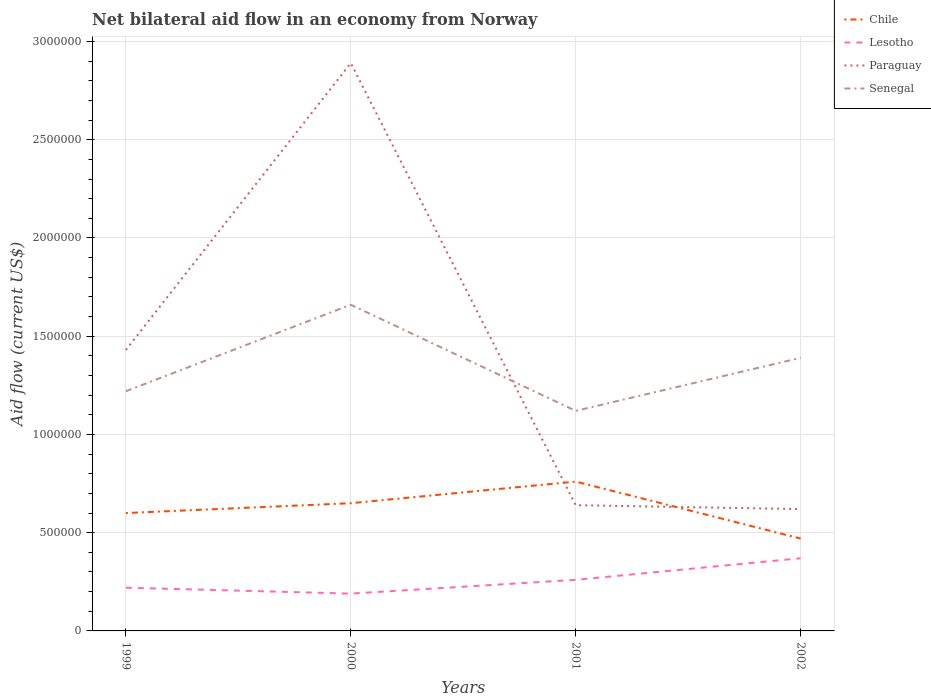Does the line corresponding to Paraguay intersect with the line corresponding to Senegal?
Your response must be concise. Yes. Is the number of lines equal to the number of legend labels?
Offer a very short reply. Yes. What is the difference between the highest and the second highest net bilateral aid flow in Paraguay?
Give a very brief answer. 2.27e+06. What is the difference between the highest and the lowest net bilateral aid flow in Senegal?
Your answer should be very brief. 2. How many lines are there?
Your answer should be compact. 4. How many years are there in the graph?
Your response must be concise. 4. What is the difference between two consecutive major ticks on the Y-axis?
Offer a terse response. 5.00e+05. Does the graph contain any zero values?
Your response must be concise. No. Does the graph contain grids?
Provide a short and direct response. Yes. Where does the legend appear in the graph?
Give a very brief answer. Top right. How are the legend labels stacked?
Offer a terse response. Vertical. What is the title of the graph?
Provide a short and direct response. Net bilateral aid flow in an economy from Norway. Does "Honduras" appear as one of the legend labels in the graph?
Provide a short and direct response. No. What is the label or title of the X-axis?
Ensure brevity in your answer.  Years. What is the Aid flow (current US$) of Paraguay in 1999?
Make the answer very short. 1.43e+06. What is the Aid flow (current US$) of Senegal in 1999?
Offer a terse response. 1.22e+06. What is the Aid flow (current US$) of Chile in 2000?
Make the answer very short. 6.50e+05. What is the Aid flow (current US$) of Paraguay in 2000?
Give a very brief answer. 2.89e+06. What is the Aid flow (current US$) of Senegal in 2000?
Offer a very short reply. 1.66e+06. What is the Aid flow (current US$) of Chile in 2001?
Offer a very short reply. 7.60e+05. What is the Aid flow (current US$) of Lesotho in 2001?
Offer a very short reply. 2.60e+05. What is the Aid flow (current US$) in Paraguay in 2001?
Ensure brevity in your answer.  6.40e+05. What is the Aid flow (current US$) of Senegal in 2001?
Provide a succinct answer. 1.12e+06. What is the Aid flow (current US$) of Chile in 2002?
Provide a succinct answer. 4.70e+05. What is the Aid flow (current US$) of Lesotho in 2002?
Provide a succinct answer. 3.70e+05. What is the Aid flow (current US$) of Paraguay in 2002?
Provide a short and direct response. 6.20e+05. What is the Aid flow (current US$) of Senegal in 2002?
Keep it short and to the point. 1.39e+06. Across all years, what is the maximum Aid flow (current US$) in Chile?
Keep it short and to the point. 7.60e+05. Across all years, what is the maximum Aid flow (current US$) in Lesotho?
Keep it short and to the point. 3.70e+05. Across all years, what is the maximum Aid flow (current US$) in Paraguay?
Offer a terse response. 2.89e+06. Across all years, what is the maximum Aid flow (current US$) in Senegal?
Provide a succinct answer. 1.66e+06. Across all years, what is the minimum Aid flow (current US$) of Paraguay?
Give a very brief answer. 6.20e+05. Across all years, what is the minimum Aid flow (current US$) of Senegal?
Your response must be concise. 1.12e+06. What is the total Aid flow (current US$) of Chile in the graph?
Make the answer very short. 2.48e+06. What is the total Aid flow (current US$) of Lesotho in the graph?
Your answer should be compact. 1.04e+06. What is the total Aid flow (current US$) of Paraguay in the graph?
Provide a succinct answer. 5.58e+06. What is the total Aid flow (current US$) of Senegal in the graph?
Offer a terse response. 5.39e+06. What is the difference between the Aid flow (current US$) of Paraguay in 1999 and that in 2000?
Make the answer very short. -1.46e+06. What is the difference between the Aid flow (current US$) in Senegal in 1999 and that in 2000?
Your answer should be very brief. -4.40e+05. What is the difference between the Aid flow (current US$) of Paraguay in 1999 and that in 2001?
Give a very brief answer. 7.90e+05. What is the difference between the Aid flow (current US$) in Senegal in 1999 and that in 2001?
Provide a short and direct response. 1.00e+05. What is the difference between the Aid flow (current US$) of Chile in 1999 and that in 2002?
Offer a very short reply. 1.30e+05. What is the difference between the Aid flow (current US$) in Paraguay in 1999 and that in 2002?
Your answer should be very brief. 8.10e+05. What is the difference between the Aid flow (current US$) in Paraguay in 2000 and that in 2001?
Offer a very short reply. 2.25e+06. What is the difference between the Aid flow (current US$) in Senegal in 2000 and that in 2001?
Offer a terse response. 5.40e+05. What is the difference between the Aid flow (current US$) in Lesotho in 2000 and that in 2002?
Give a very brief answer. -1.80e+05. What is the difference between the Aid flow (current US$) of Paraguay in 2000 and that in 2002?
Ensure brevity in your answer.  2.27e+06. What is the difference between the Aid flow (current US$) in Lesotho in 2001 and that in 2002?
Ensure brevity in your answer.  -1.10e+05. What is the difference between the Aid flow (current US$) of Senegal in 2001 and that in 2002?
Your response must be concise. -2.70e+05. What is the difference between the Aid flow (current US$) of Chile in 1999 and the Aid flow (current US$) of Lesotho in 2000?
Give a very brief answer. 4.10e+05. What is the difference between the Aid flow (current US$) in Chile in 1999 and the Aid flow (current US$) in Paraguay in 2000?
Your answer should be compact. -2.29e+06. What is the difference between the Aid flow (current US$) of Chile in 1999 and the Aid flow (current US$) of Senegal in 2000?
Keep it short and to the point. -1.06e+06. What is the difference between the Aid flow (current US$) of Lesotho in 1999 and the Aid flow (current US$) of Paraguay in 2000?
Provide a succinct answer. -2.67e+06. What is the difference between the Aid flow (current US$) in Lesotho in 1999 and the Aid flow (current US$) in Senegal in 2000?
Provide a short and direct response. -1.44e+06. What is the difference between the Aid flow (current US$) in Paraguay in 1999 and the Aid flow (current US$) in Senegal in 2000?
Provide a short and direct response. -2.30e+05. What is the difference between the Aid flow (current US$) of Chile in 1999 and the Aid flow (current US$) of Lesotho in 2001?
Offer a terse response. 3.40e+05. What is the difference between the Aid flow (current US$) in Chile in 1999 and the Aid flow (current US$) in Paraguay in 2001?
Your answer should be very brief. -4.00e+04. What is the difference between the Aid flow (current US$) of Chile in 1999 and the Aid flow (current US$) of Senegal in 2001?
Make the answer very short. -5.20e+05. What is the difference between the Aid flow (current US$) in Lesotho in 1999 and the Aid flow (current US$) in Paraguay in 2001?
Make the answer very short. -4.20e+05. What is the difference between the Aid flow (current US$) in Lesotho in 1999 and the Aid flow (current US$) in Senegal in 2001?
Provide a succinct answer. -9.00e+05. What is the difference between the Aid flow (current US$) of Chile in 1999 and the Aid flow (current US$) of Paraguay in 2002?
Your answer should be compact. -2.00e+04. What is the difference between the Aid flow (current US$) of Chile in 1999 and the Aid flow (current US$) of Senegal in 2002?
Make the answer very short. -7.90e+05. What is the difference between the Aid flow (current US$) in Lesotho in 1999 and the Aid flow (current US$) in Paraguay in 2002?
Your response must be concise. -4.00e+05. What is the difference between the Aid flow (current US$) in Lesotho in 1999 and the Aid flow (current US$) in Senegal in 2002?
Keep it short and to the point. -1.17e+06. What is the difference between the Aid flow (current US$) of Paraguay in 1999 and the Aid flow (current US$) of Senegal in 2002?
Ensure brevity in your answer.  4.00e+04. What is the difference between the Aid flow (current US$) in Chile in 2000 and the Aid flow (current US$) in Senegal in 2001?
Your answer should be very brief. -4.70e+05. What is the difference between the Aid flow (current US$) of Lesotho in 2000 and the Aid flow (current US$) of Paraguay in 2001?
Your answer should be very brief. -4.50e+05. What is the difference between the Aid flow (current US$) of Lesotho in 2000 and the Aid flow (current US$) of Senegal in 2001?
Keep it short and to the point. -9.30e+05. What is the difference between the Aid flow (current US$) in Paraguay in 2000 and the Aid flow (current US$) in Senegal in 2001?
Make the answer very short. 1.77e+06. What is the difference between the Aid flow (current US$) of Chile in 2000 and the Aid flow (current US$) of Lesotho in 2002?
Ensure brevity in your answer.  2.80e+05. What is the difference between the Aid flow (current US$) in Chile in 2000 and the Aid flow (current US$) in Paraguay in 2002?
Offer a very short reply. 3.00e+04. What is the difference between the Aid flow (current US$) in Chile in 2000 and the Aid flow (current US$) in Senegal in 2002?
Provide a short and direct response. -7.40e+05. What is the difference between the Aid flow (current US$) in Lesotho in 2000 and the Aid flow (current US$) in Paraguay in 2002?
Offer a terse response. -4.30e+05. What is the difference between the Aid flow (current US$) in Lesotho in 2000 and the Aid flow (current US$) in Senegal in 2002?
Your answer should be compact. -1.20e+06. What is the difference between the Aid flow (current US$) of Paraguay in 2000 and the Aid flow (current US$) of Senegal in 2002?
Your answer should be compact. 1.50e+06. What is the difference between the Aid flow (current US$) of Chile in 2001 and the Aid flow (current US$) of Paraguay in 2002?
Provide a short and direct response. 1.40e+05. What is the difference between the Aid flow (current US$) of Chile in 2001 and the Aid flow (current US$) of Senegal in 2002?
Your answer should be compact. -6.30e+05. What is the difference between the Aid flow (current US$) of Lesotho in 2001 and the Aid flow (current US$) of Paraguay in 2002?
Offer a very short reply. -3.60e+05. What is the difference between the Aid flow (current US$) in Lesotho in 2001 and the Aid flow (current US$) in Senegal in 2002?
Keep it short and to the point. -1.13e+06. What is the difference between the Aid flow (current US$) in Paraguay in 2001 and the Aid flow (current US$) in Senegal in 2002?
Keep it short and to the point. -7.50e+05. What is the average Aid flow (current US$) in Chile per year?
Keep it short and to the point. 6.20e+05. What is the average Aid flow (current US$) of Paraguay per year?
Your answer should be very brief. 1.40e+06. What is the average Aid flow (current US$) in Senegal per year?
Offer a very short reply. 1.35e+06. In the year 1999, what is the difference between the Aid flow (current US$) of Chile and Aid flow (current US$) of Lesotho?
Keep it short and to the point. 3.80e+05. In the year 1999, what is the difference between the Aid flow (current US$) of Chile and Aid flow (current US$) of Paraguay?
Give a very brief answer. -8.30e+05. In the year 1999, what is the difference between the Aid flow (current US$) of Chile and Aid flow (current US$) of Senegal?
Ensure brevity in your answer.  -6.20e+05. In the year 1999, what is the difference between the Aid flow (current US$) of Lesotho and Aid flow (current US$) of Paraguay?
Your answer should be very brief. -1.21e+06. In the year 2000, what is the difference between the Aid flow (current US$) of Chile and Aid flow (current US$) of Paraguay?
Your response must be concise. -2.24e+06. In the year 2000, what is the difference between the Aid flow (current US$) in Chile and Aid flow (current US$) in Senegal?
Your answer should be very brief. -1.01e+06. In the year 2000, what is the difference between the Aid flow (current US$) in Lesotho and Aid flow (current US$) in Paraguay?
Provide a succinct answer. -2.70e+06. In the year 2000, what is the difference between the Aid flow (current US$) of Lesotho and Aid flow (current US$) of Senegal?
Your answer should be compact. -1.47e+06. In the year 2000, what is the difference between the Aid flow (current US$) of Paraguay and Aid flow (current US$) of Senegal?
Your response must be concise. 1.23e+06. In the year 2001, what is the difference between the Aid flow (current US$) of Chile and Aid flow (current US$) of Senegal?
Provide a short and direct response. -3.60e+05. In the year 2001, what is the difference between the Aid flow (current US$) in Lesotho and Aid flow (current US$) in Paraguay?
Make the answer very short. -3.80e+05. In the year 2001, what is the difference between the Aid flow (current US$) of Lesotho and Aid flow (current US$) of Senegal?
Your answer should be very brief. -8.60e+05. In the year 2001, what is the difference between the Aid flow (current US$) of Paraguay and Aid flow (current US$) of Senegal?
Offer a terse response. -4.80e+05. In the year 2002, what is the difference between the Aid flow (current US$) in Chile and Aid flow (current US$) in Lesotho?
Ensure brevity in your answer.  1.00e+05. In the year 2002, what is the difference between the Aid flow (current US$) of Chile and Aid flow (current US$) of Senegal?
Keep it short and to the point. -9.20e+05. In the year 2002, what is the difference between the Aid flow (current US$) of Lesotho and Aid flow (current US$) of Senegal?
Provide a short and direct response. -1.02e+06. In the year 2002, what is the difference between the Aid flow (current US$) in Paraguay and Aid flow (current US$) in Senegal?
Provide a succinct answer. -7.70e+05. What is the ratio of the Aid flow (current US$) in Chile in 1999 to that in 2000?
Your answer should be compact. 0.92. What is the ratio of the Aid flow (current US$) in Lesotho in 1999 to that in 2000?
Your answer should be very brief. 1.16. What is the ratio of the Aid flow (current US$) of Paraguay in 1999 to that in 2000?
Offer a terse response. 0.49. What is the ratio of the Aid flow (current US$) in Senegal in 1999 to that in 2000?
Provide a succinct answer. 0.73. What is the ratio of the Aid flow (current US$) of Chile in 1999 to that in 2001?
Keep it short and to the point. 0.79. What is the ratio of the Aid flow (current US$) in Lesotho in 1999 to that in 2001?
Make the answer very short. 0.85. What is the ratio of the Aid flow (current US$) in Paraguay in 1999 to that in 2001?
Offer a terse response. 2.23. What is the ratio of the Aid flow (current US$) of Senegal in 1999 to that in 2001?
Keep it short and to the point. 1.09. What is the ratio of the Aid flow (current US$) of Chile in 1999 to that in 2002?
Your response must be concise. 1.28. What is the ratio of the Aid flow (current US$) of Lesotho in 1999 to that in 2002?
Your answer should be compact. 0.59. What is the ratio of the Aid flow (current US$) in Paraguay in 1999 to that in 2002?
Your answer should be very brief. 2.31. What is the ratio of the Aid flow (current US$) in Senegal in 1999 to that in 2002?
Your response must be concise. 0.88. What is the ratio of the Aid flow (current US$) of Chile in 2000 to that in 2001?
Keep it short and to the point. 0.86. What is the ratio of the Aid flow (current US$) in Lesotho in 2000 to that in 2001?
Make the answer very short. 0.73. What is the ratio of the Aid flow (current US$) in Paraguay in 2000 to that in 2001?
Your answer should be very brief. 4.52. What is the ratio of the Aid flow (current US$) of Senegal in 2000 to that in 2001?
Provide a short and direct response. 1.48. What is the ratio of the Aid flow (current US$) of Chile in 2000 to that in 2002?
Provide a succinct answer. 1.38. What is the ratio of the Aid flow (current US$) of Lesotho in 2000 to that in 2002?
Provide a short and direct response. 0.51. What is the ratio of the Aid flow (current US$) of Paraguay in 2000 to that in 2002?
Provide a succinct answer. 4.66. What is the ratio of the Aid flow (current US$) of Senegal in 2000 to that in 2002?
Provide a short and direct response. 1.19. What is the ratio of the Aid flow (current US$) in Chile in 2001 to that in 2002?
Offer a very short reply. 1.62. What is the ratio of the Aid flow (current US$) of Lesotho in 2001 to that in 2002?
Provide a short and direct response. 0.7. What is the ratio of the Aid flow (current US$) of Paraguay in 2001 to that in 2002?
Your answer should be very brief. 1.03. What is the ratio of the Aid flow (current US$) of Senegal in 2001 to that in 2002?
Offer a terse response. 0.81. What is the difference between the highest and the second highest Aid flow (current US$) in Lesotho?
Your response must be concise. 1.10e+05. What is the difference between the highest and the second highest Aid flow (current US$) in Paraguay?
Provide a short and direct response. 1.46e+06. What is the difference between the highest and the second highest Aid flow (current US$) of Senegal?
Provide a succinct answer. 2.70e+05. What is the difference between the highest and the lowest Aid flow (current US$) in Paraguay?
Provide a succinct answer. 2.27e+06. What is the difference between the highest and the lowest Aid flow (current US$) of Senegal?
Offer a very short reply. 5.40e+05. 